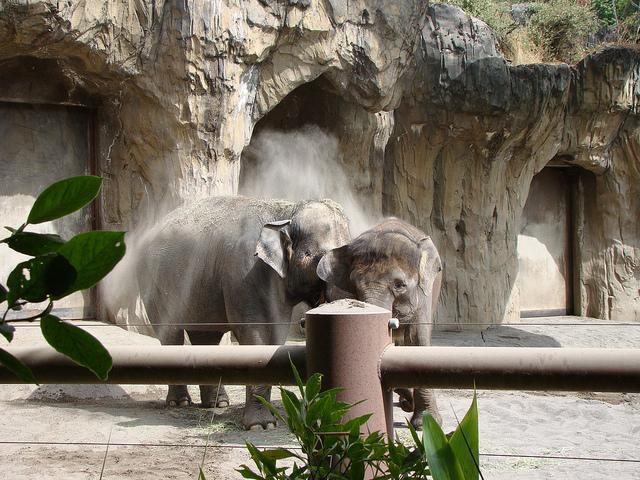How many elephants are in this photo?
Give a very brief answer. 2. How many elephants are there?
Give a very brief answer. 2. 